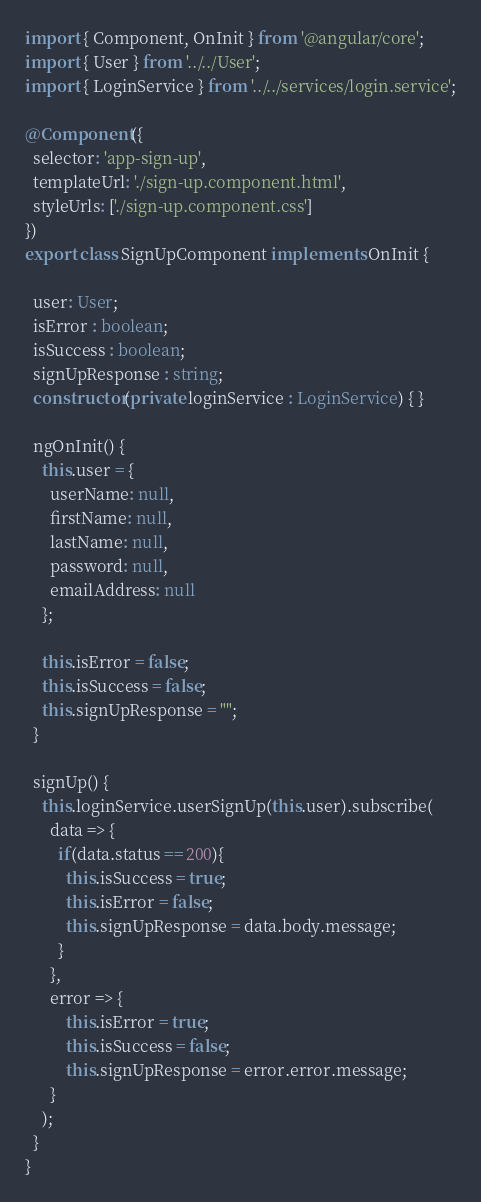<code> <loc_0><loc_0><loc_500><loc_500><_TypeScript_>import { Component, OnInit } from '@angular/core';
import { User } from '../../User';
import { LoginService } from '../../services/login.service';

@Component({
  selector: 'app-sign-up',
  templateUrl: './sign-up.component.html',
  styleUrls: ['./sign-up.component.css']
})
export class SignUpComponent implements OnInit {

  user: User;
  isError : boolean;
  isSuccess : boolean;
  signUpResponse : string;
  constructor(private loginService : LoginService) { }

  ngOnInit() {
    this.user = {
      userName: null,
      firstName: null,
      lastName: null,
      password: null,
      emailAddress: null
    };
    
    this.isError = false;
    this.isSuccess = false;
    this.signUpResponse = "";
  }

  signUp() {
    this.loginService.userSignUp(this.user).subscribe(
      data => {
        if(data.status == 200){
          this.isSuccess = true;
          this.isError = false;
          this.signUpResponse = data.body.message;
        }        
      },
      error => {
          this.isError = true;
          this.isSuccess = false;
          this.signUpResponse = error.error.message;
      }
    );
  }
}
</code> 